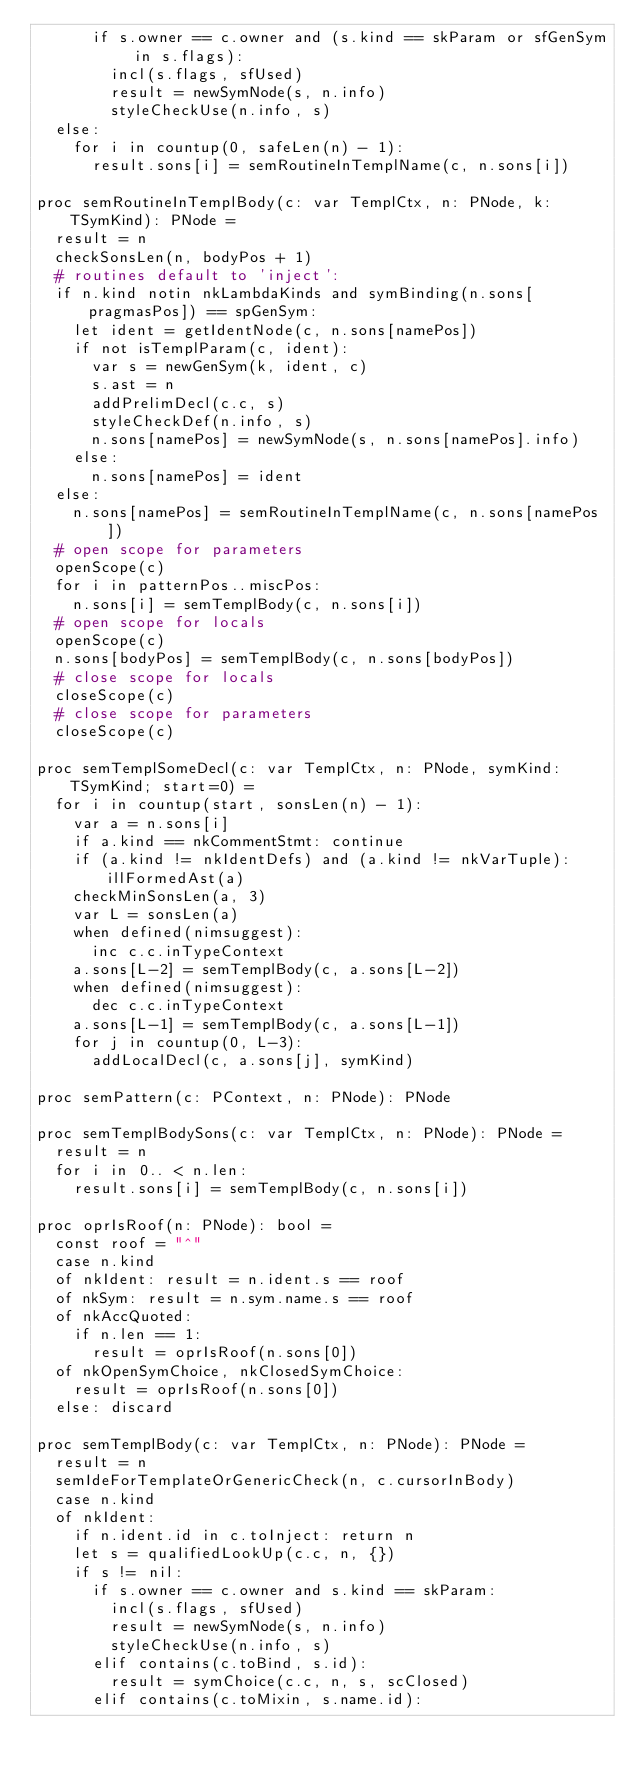Convert code to text. <code><loc_0><loc_0><loc_500><loc_500><_Nim_>      if s.owner == c.owner and (s.kind == skParam or sfGenSym in s.flags):
        incl(s.flags, sfUsed)
        result = newSymNode(s, n.info)
        styleCheckUse(n.info, s)
  else:
    for i in countup(0, safeLen(n) - 1):
      result.sons[i] = semRoutineInTemplName(c, n.sons[i])

proc semRoutineInTemplBody(c: var TemplCtx, n: PNode, k: TSymKind): PNode =
  result = n
  checkSonsLen(n, bodyPos + 1)
  # routines default to 'inject':
  if n.kind notin nkLambdaKinds and symBinding(n.sons[pragmasPos]) == spGenSym:
    let ident = getIdentNode(c, n.sons[namePos])
    if not isTemplParam(c, ident):
      var s = newGenSym(k, ident, c)
      s.ast = n
      addPrelimDecl(c.c, s)
      styleCheckDef(n.info, s)
      n.sons[namePos] = newSymNode(s, n.sons[namePos].info)
    else:
      n.sons[namePos] = ident
  else:
    n.sons[namePos] = semRoutineInTemplName(c, n.sons[namePos])
  # open scope for parameters
  openScope(c)
  for i in patternPos..miscPos:
    n.sons[i] = semTemplBody(c, n.sons[i])
  # open scope for locals
  openScope(c)
  n.sons[bodyPos] = semTemplBody(c, n.sons[bodyPos])
  # close scope for locals
  closeScope(c)
  # close scope for parameters
  closeScope(c)

proc semTemplSomeDecl(c: var TemplCtx, n: PNode, symKind: TSymKind; start=0) =
  for i in countup(start, sonsLen(n) - 1):
    var a = n.sons[i]
    if a.kind == nkCommentStmt: continue
    if (a.kind != nkIdentDefs) and (a.kind != nkVarTuple): illFormedAst(a)
    checkMinSonsLen(a, 3)
    var L = sonsLen(a)
    when defined(nimsuggest):
      inc c.c.inTypeContext
    a.sons[L-2] = semTemplBody(c, a.sons[L-2])
    when defined(nimsuggest):
      dec c.c.inTypeContext
    a.sons[L-1] = semTemplBody(c, a.sons[L-1])
    for j in countup(0, L-3):
      addLocalDecl(c, a.sons[j], symKind)

proc semPattern(c: PContext, n: PNode): PNode

proc semTemplBodySons(c: var TemplCtx, n: PNode): PNode =
  result = n
  for i in 0.. < n.len:
    result.sons[i] = semTemplBody(c, n.sons[i])

proc oprIsRoof(n: PNode): bool =
  const roof = "^"
  case n.kind
  of nkIdent: result = n.ident.s == roof
  of nkSym: result = n.sym.name.s == roof
  of nkAccQuoted:
    if n.len == 1:
      result = oprIsRoof(n.sons[0])
  of nkOpenSymChoice, nkClosedSymChoice:
    result = oprIsRoof(n.sons[0])
  else: discard

proc semTemplBody(c: var TemplCtx, n: PNode): PNode =
  result = n
  semIdeForTemplateOrGenericCheck(n, c.cursorInBody)
  case n.kind
  of nkIdent:
    if n.ident.id in c.toInject: return n
    let s = qualifiedLookUp(c.c, n, {})
    if s != nil:
      if s.owner == c.owner and s.kind == skParam:
        incl(s.flags, sfUsed)
        result = newSymNode(s, n.info)
        styleCheckUse(n.info, s)
      elif contains(c.toBind, s.id):
        result = symChoice(c.c, n, s, scClosed)
      elif contains(c.toMixin, s.name.id):</code> 